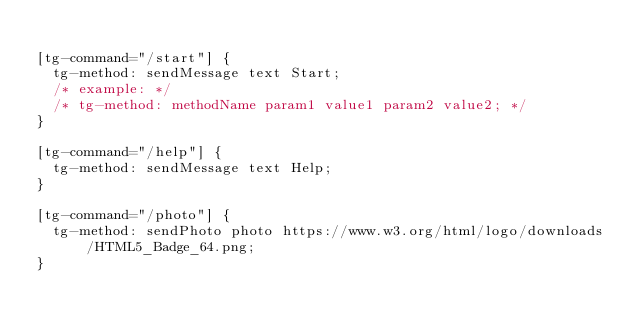<code> <loc_0><loc_0><loc_500><loc_500><_CSS_>
[tg-command="/start"] {
  tg-method: sendMessage text Start;
  /* example: */
  /* tg-method: methodName param1 value1 param2 value2; */
}

[tg-command="/help"] {
  tg-method: sendMessage text Help;
}

[tg-command="/photo"] {
  tg-method: sendPhoto photo https://www.w3.org/html/logo/downloads/HTML5_Badge_64.png;
}
</code> 